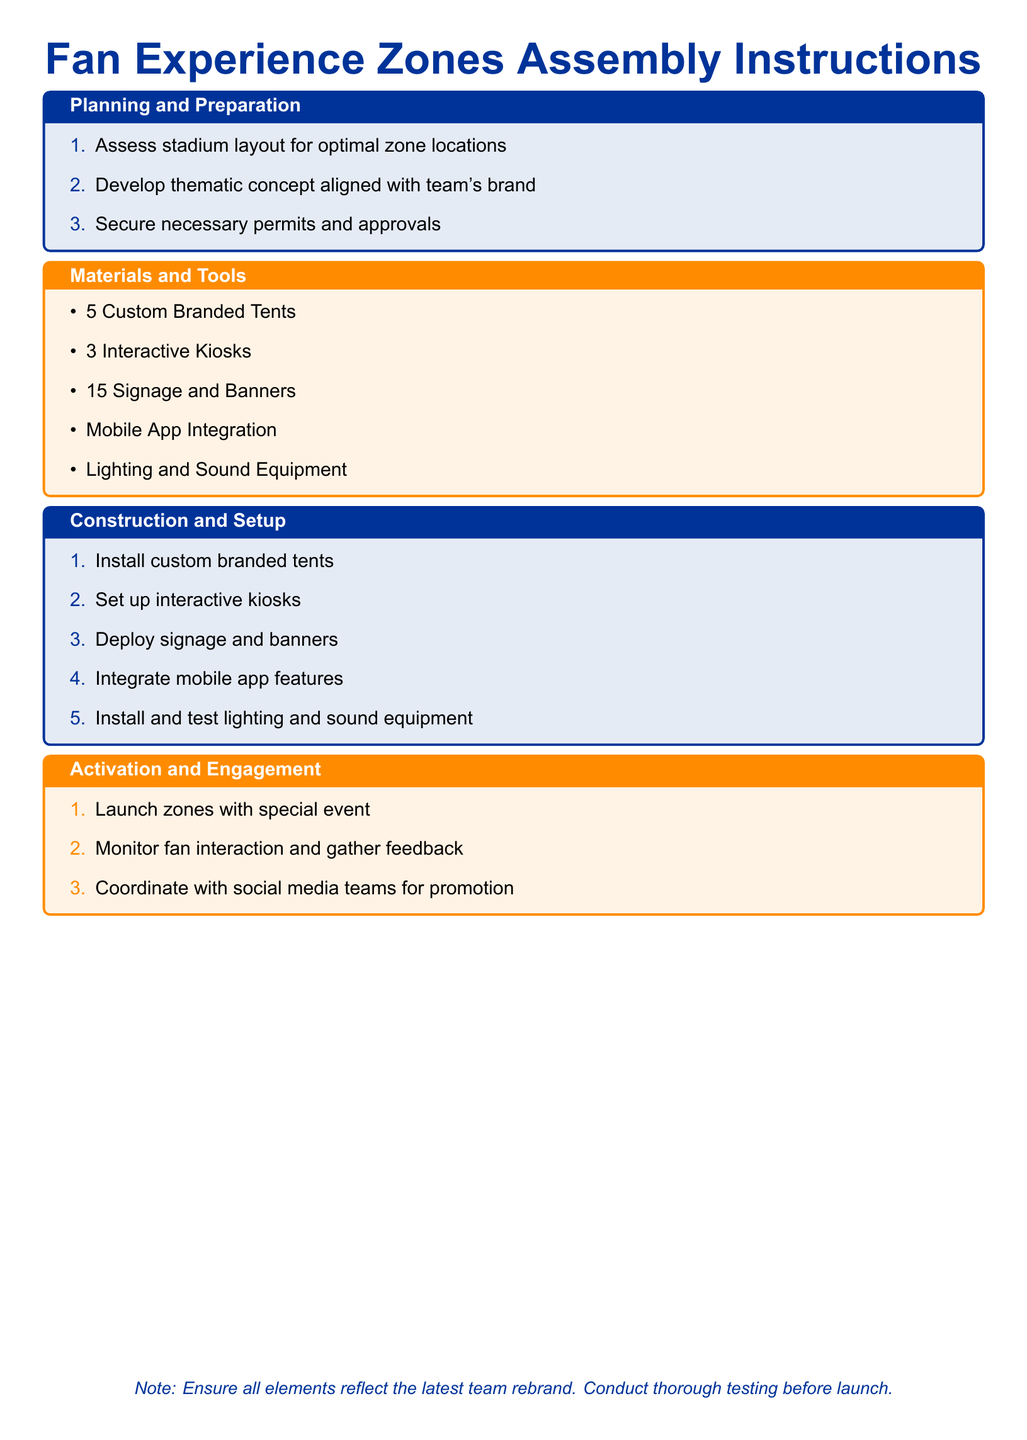What is the title of the document? The document is titled as indicated at the top of the page.
Answer: Fan Experience Zones Assembly Instructions How many custom branded tents are needed? The document lists the number of tents required in the "Materials and Tools" section.
Answer: 5 What is the first step in the planning process? The first item in the "Planning and Preparation" section indicates the initial step.
Answer: Assess stadium layout for optimal zone locations What type of equipment must be installed and tested? The "Construction and Setup" section mentions the types of equipment needed.
Answer: Lighting and Sound Equipment What is required for fan engagement after setting up the zones? The "Activation and Engagement" section specifies a necessary action for engagement.
Answer: Launch zones with special event How many interactive kiosks are mentioned? The required number of kiosks is found in the "Materials and Tools" section.
Answer: 3 What is the purpose of coordinating with social media teams? The "Activation and Engagement" section provides the reason for this coordination.
Answer: Promotion What should be reflected in all elements of the zones? The note at the bottom provides a crucial aspect to consider.
Answer: Latest team rebrand 